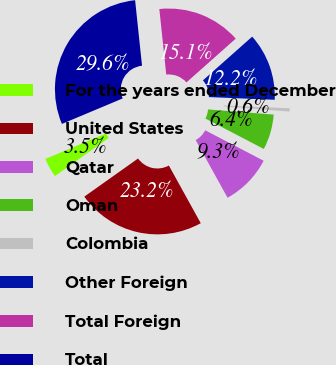Convert chart to OTSL. <chart><loc_0><loc_0><loc_500><loc_500><pie_chart><fcel>For the years ended December<fcel>United States<fcel>Qatar<fcel>Oman<fcel>Colombia<fcel>Other Foreign<fcel>Total Foreign<fcel>Total<nl><fcel>3.5%<fcel>23.22%<fcel>9.31%<fcel>6.4%<fcel>0.59%<fcel>12.21%<fcel>15.12%<fcel>29.64%<nl></chart> 